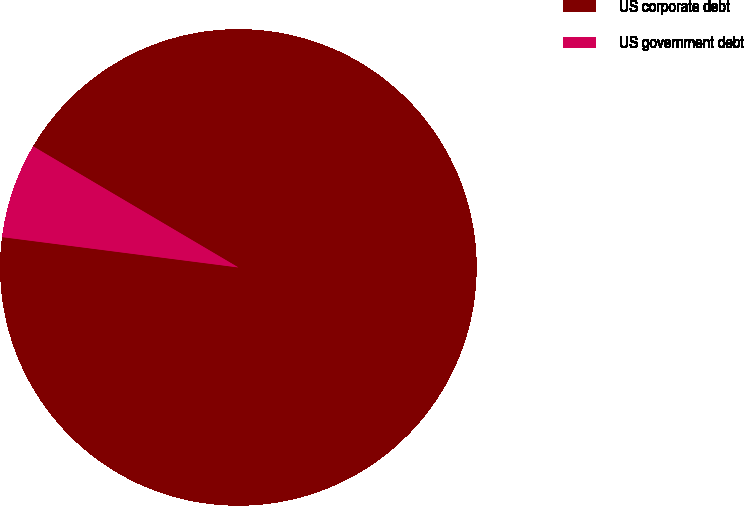Convert chart. <chart><loc_0><loc_0><loc_500><loc_500><pie_chart><fcel>US corporate debt<fcel>US government debt<nl><fcel>93.55%<fcel>6.45%<nl></chart> 